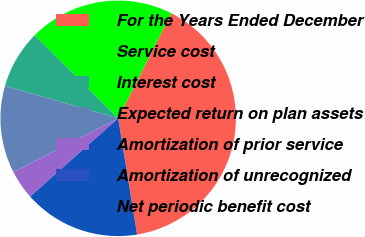Convert chart to OTSL. <chart><loc_0><loc_0><loc_500><loc_500><pie_chart><fcel>For the Years Ended December<fcel>Service cost<fcel>Interest cost<fcel>Expected return on plan assets<fcel>Amortization of prior service<fcel>Amortization of unrecognized<fcel>Net periodic benefit cost<nl><fcel>39.98%<fcel>20.0%<fcel>8.0%<fcel>12.0%<fcel>4.01%<fcel>0.01%<fcel>16.0%<nl></chart> 